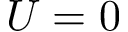Convert formula to latex. <formula><loc_0><loc_0><loc_500><loc_500>U = 0</formula> 